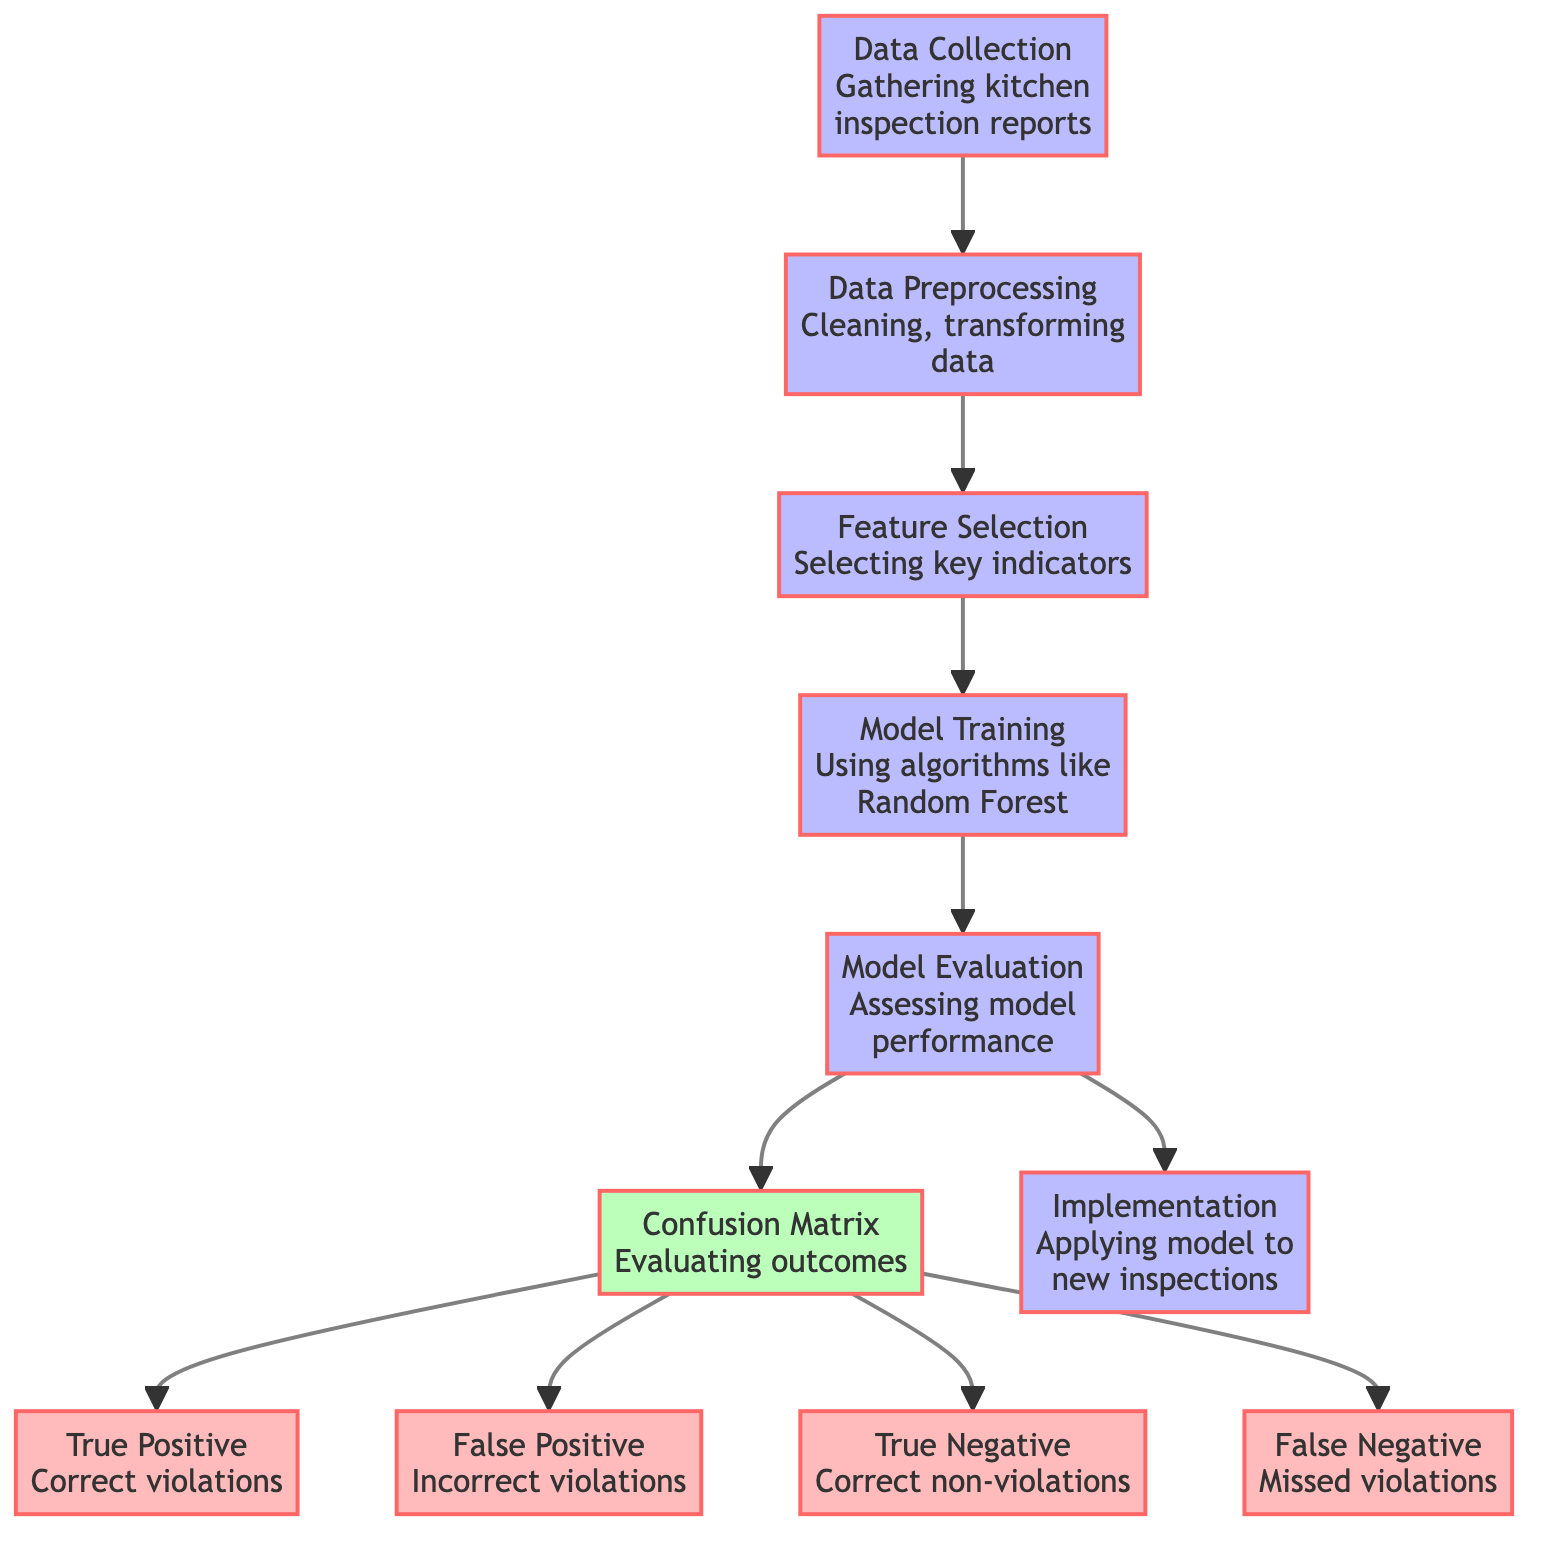What is the first step in the diagram? The first step in the diagram is "Data Collection," which involves gathering kitchen inspection reports. This is the starting point of the process.
Answer: Data Collection How many outcome types are represented in the confusion matrix? The confusion matrix in the diagram has four outcome types: True Positive, False Positive, True Negative, and False Negative. These are the four key results that can occur.
Answer: Four What node follows "Model Evaluation"? After "Model Evaluation," the next node is "Confusion Matrix." This indicates that evaluating the model's performance leads to assessing outcomes through the confusion matrix.
Answer: Confusion Matrix What does "True Positive" represent in the diagram? "True Positive" represents the scenario where violations are correctly identified as violations. This is a positive outcome for the model.
Answer: Correct violations If a violation is missed, which node represents this outcome? The node representing a missed violation is "False Negative." This indicates a situation where violations are not detected, which is an error in the model.
Answer: False Negative Which algorithm is mentioned in the "Model Training" step? The algorithm mentioned in the "Model Training" step is "Random Forest." This implies that the model is trained using this specific machine learning algorithm.
Answer: Random Forest What is the purpose of the "Implementation" node in the diagram? The "Implementation" node signifies the application of the developed model to new inspections, indicating practical use of the model after evaluation.
Answer: Applying model to new inspections What step involves cleaning and transforming data? The step that involves cleaning and transforming data is "Data Preprocessing." This step is crucial for preparing the data for further analysis.
Answer: Data Preprocessing What is the last step in the process flow of the diagram? The last step in the process flow is "Implementation," which represents the deployment of the model. It is the final stage after the model evaluation.
Answer: Implementation 